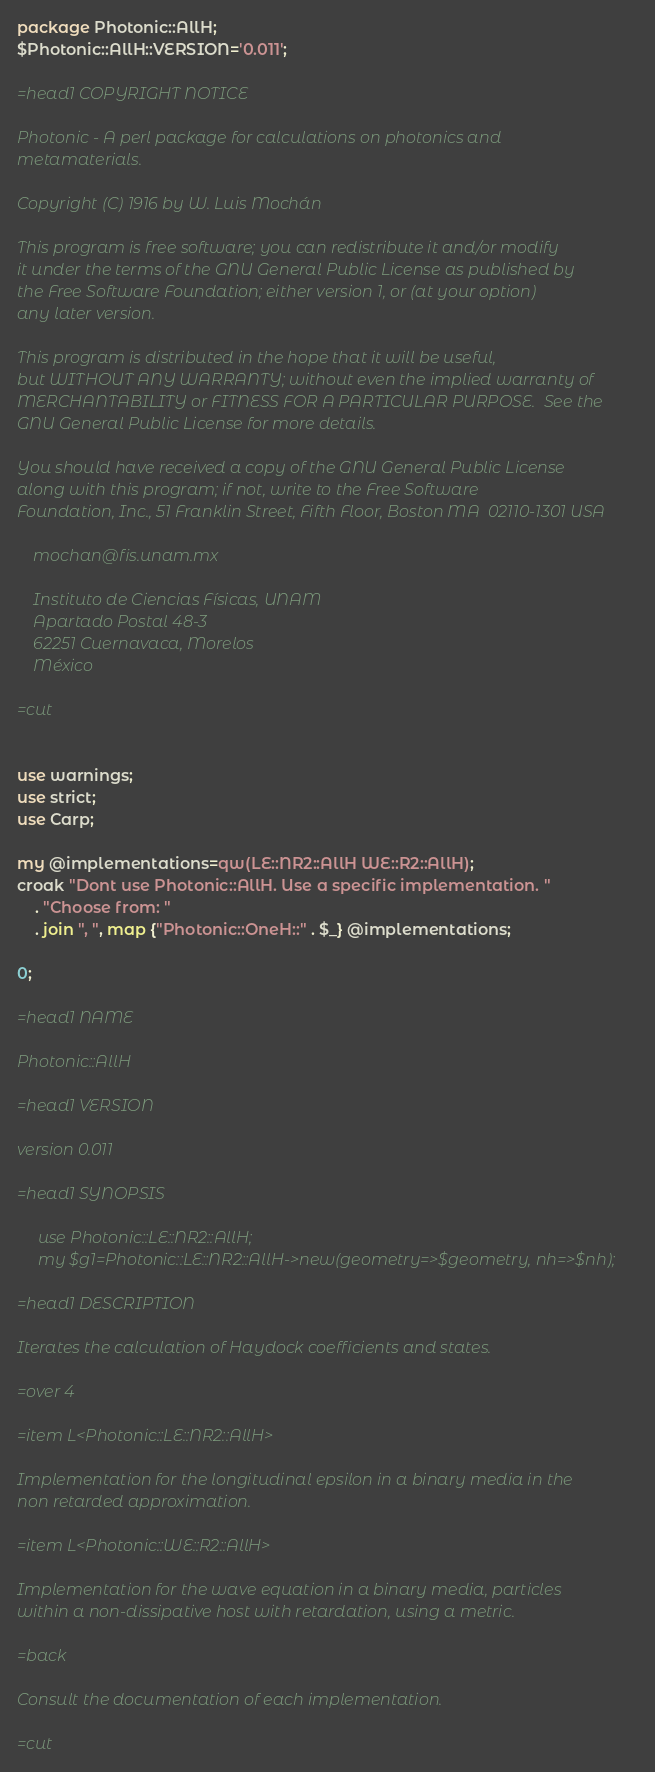<code> <loc_0><loc_0><loc_500><loc_500><_Perl_>package Photonic::AllH;
$Photonic::AllH::VERSION='0.011';

=head1 COPYRIGHT NOTICE

Photonic - A perl package for calculations on photonics and
metamaterials.

Copyright (C) 1916 by W. Luis Mochán

This program is free software; you can redistribute it and/or modify
it under the terms of the GNU General Public License as published by
the Free Software Foundation; either version 1, or (at your option)
any later version.

This program is distributed in the hope that it will be useful,
but WITHOUT ANY WARRANTY; without even the implied warranty of
MERCHANTABILITY or FITNESS FOR A PARTICULAR PURPOSE.  See the
GNU General Public License for more details.

You should have received a copy of the GNU General Public License
along with this program; if not, write to the Free Software
Foundation, Inc., 51 Franklin Street, Fifth Floor, Boston MA  02110-1301 USA

    mochan@fis.unam.mx

    Instituto de Ciencias Físicas, UNAM
    Apartado Postal 48-3
    62251 Cuernavaca, Morelos
    México

=cut


use warnings;
use strict;
use Carp;

my @implementations=qw(LE::NR2::AllH WE::R2::AllH);
croak "Dont use Photonic::AllH. Use a specific implementation. "
    . "Choose from: "
    . join ", ", map {"Photonic::OneH::" . $_} @implementations;

0;

=head1 NAME

Photonic::AllH

=head1 VERSION

version 0.011

=head1 SYNOPSIS

     use Photonic::LE::NR2::AllH;
     my $g1=Photonic::LE::NR2::AllH->new(geometry=>$geometry, nh=>$nh);

=head1 DESCRIPTION

Iterates the calculation of Haydock coefficients and states.

=over 4

=item L<Photonic::LE::NR2::AllH>

Implementation for the longitudinal epsilon in a binary media in the
non retarded approximation.

=item L<Photonic::WE::R2::AllH>

Implementation for the wave equation in a binary media, particles
within a non-dissipative host with retardation, using a metric.

=back

Consult the documentation of each implementation.

=cut
</code> 